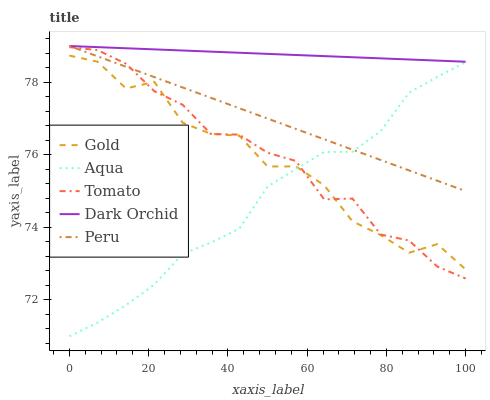Does Peru have the minimum area under the curve?
Answer yes or no. No. Does Peru have the maximum area under the curve?
Answer yes or no. No. Is Aqua the smoothest?
Answer yes or no. No. Is Aqua the roughest?
Answer yes or no. No. Does Peru have the lowest value?
Answer yes or no. No. Does Aqua have the highest value?
Answer yes or no. No. Is Gold less than Peru?
Answer yes or no. Yes. Is Peru greater than Gold?
Answer yes or no. Yes. Does Gold intersect Peru?
Answer yes or no. No. 